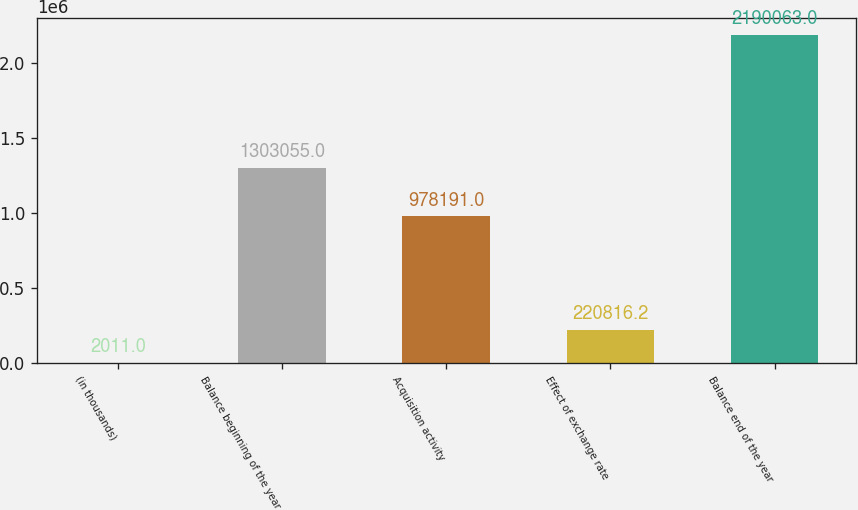Convert chart. <chart><loc_0><loc_0><loc_500><loc_500><bar_chart><fcel>(in thousands)<fcel>Balance beginning of the year<fcel>Acquisition activity<fcel>Effect of exchange rate<fcel>Balance end of the year<nl><fcel>2011<fcel>1.30306e+06<fcel>978191<fcel>220816<fcel>2.19006e+06<nl></chart> 